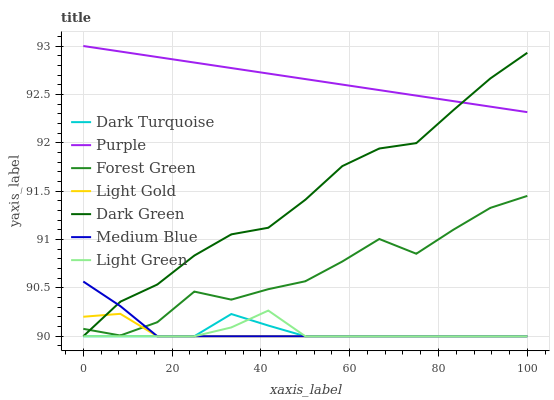Does Light Gold have the minimum area under the curve?
Answer yes or no. Yes. Does Purple have the maximum area under the curve?
Answer yes or no. Yes. Does Dark Turquoise have the minimum area under the curve?
Answer yes or no. No. Does Dark Turquoise have the maximum area under the curve?
Answer yes or no. No. Is Purple the smoothest?
Answer yes or no. Yes. Is Forest Green the roughest?
Answer yes or no. Yes. Is Dark Turquoise the smoothest?
Answer yes or no. No. Is Dark Turquoise the roughest?
Answer yes or no. No. Does Dark Turquoise have the lowest value?
Answer yes or no. Yes. Does Forest Green have the lowest value?
Answer yes or no. No. Does Purple have the highest value?
Answer yes or no. Yes. Does Medium Blue have the highest value?
Answer yes or no. No. Is Dark Turquoise less than Purple?
Answer yes or no. Yes. Is Forest Green greater than Light Green?
Answer yes or no. Yes. Does Dark Green intersect Medium Blue?
Answer yes or no. Yes. Is Dark Green less than Medium Blue?
Answer yes or no. No. Is Dark Green greater than Medium Blue?
Answer yes or no. No. Does Dark Turquoise intersect Purple?
Answer yes or no. No. 